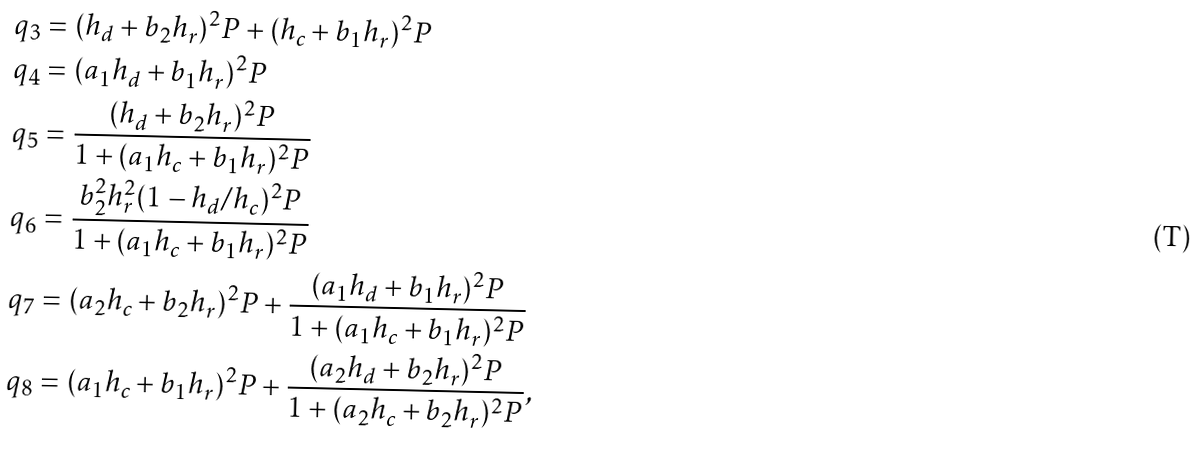<formula> <loc_0><loc_0><loc_500><loc_500>q _ { 3 } & = ( h _ { d } + b _ { 2 } h _ { r } ) ^ { 2 } P + ( h _ { c } + b _ { 1 } h _ { r } ) ^ { 2 } P \\ q _ { 4 } & = ( a _ { 1 } h _ { d } + b _ { 1 } h _ { r } ) ^ { 2 } P \\ q _ { 5 } & = \frac { ( h _ { d } + b _ { 2 } h _ { r } ) ^ { 2 } P } { 1 + ( a _ { 1 } h _ { c } + b _ { 1 } h _ { r } ) ^ { 2 } P } \\ q _ { 6 } & = \frac { b _ { 2 } ^ { 2 } h _ { r } ^ { 2 } ( 1 - h _ { d } / h _ { c } ) ^ { 2 } P } { 1 + ( a _ { 1 } h _ { c } + b _ { 1 } h _ { r } ) ^ { 2 } P } \\ q _ { 7 } & = ( a _ { 2 } h _ { c } + b _ { 2 } h _ { r } ) ^ { 2 } P + \frac { ( a _ { 1 } h _ { d } + b _ { 1 } h _ { r } ) ^ { 2 } P } { 1 + ( a _ { 1 } h _ { c } + b _ { 1 } h _ { r } ) ^ { 2 } P } \\ q _ { 8 } & = ( a _ { 1 } h _ { c } + b _ { 1 } h _ { r } ) ^ { 2 } P + \frac { ( a _ { 2 } h _ { d } + b _ { 2 } h _ { r } ) ^ { 2 } P } { 1 + ( a _ { 2 } h _ { c } + b _ { 2 } h _ { r } ) ^ { 2 } P } ,</formula> 